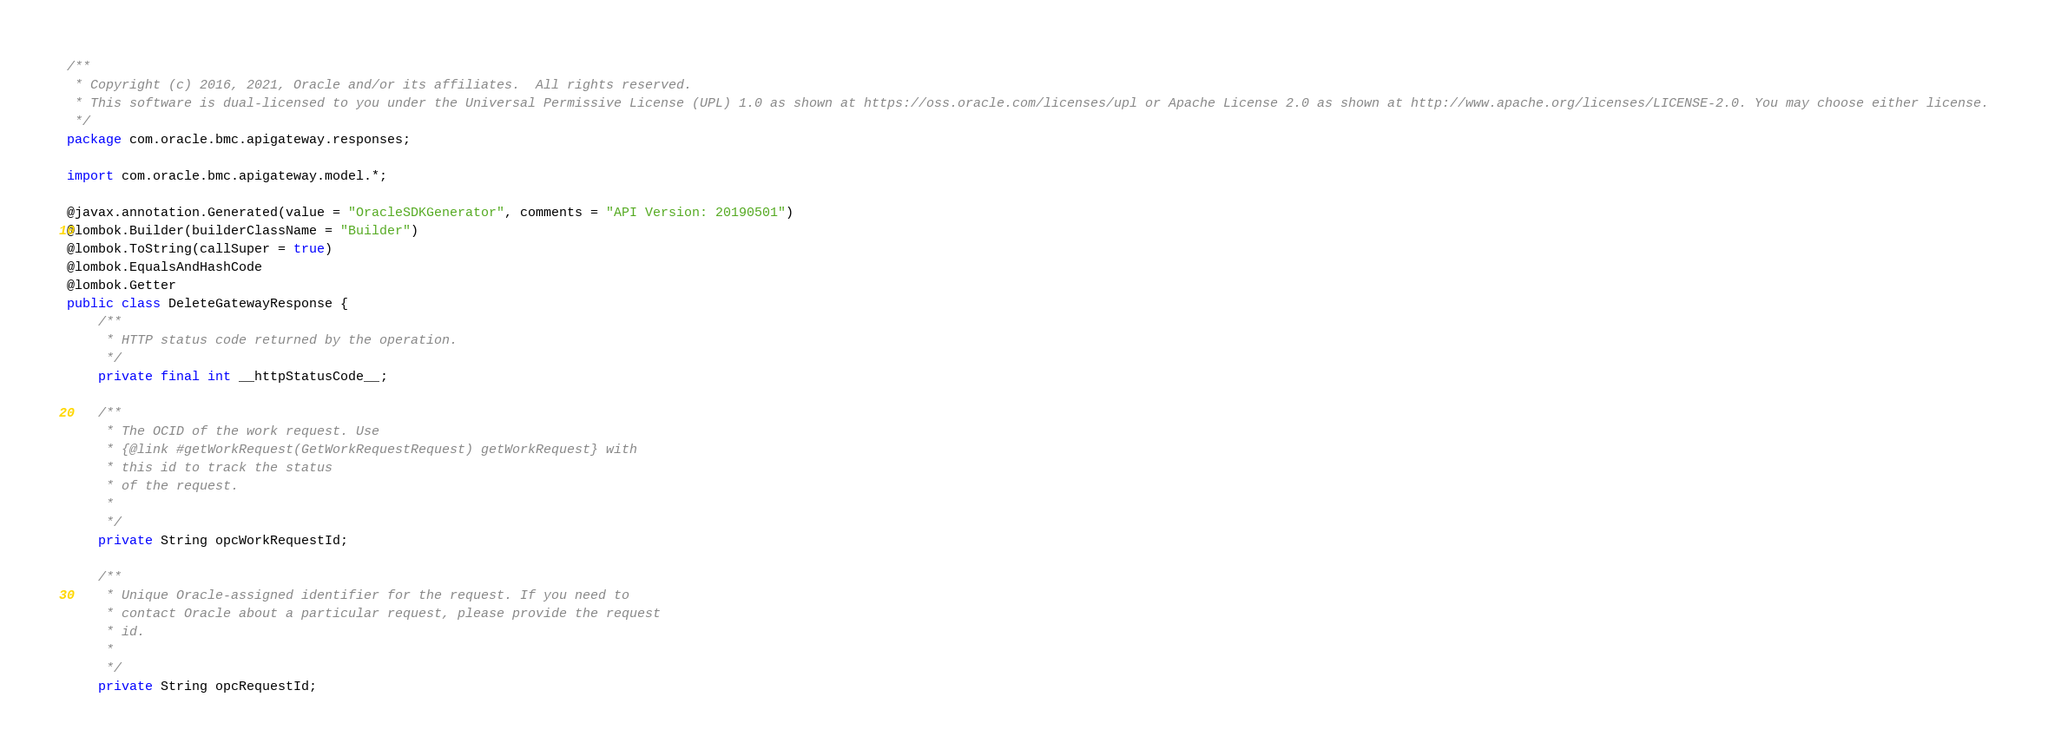Convert code to text. <code><loc_0><loc_0><loc_500><loc_500><_Java_>/**
 * Copyright (c) 2016, 2021, Oracle and/or its affiliates.  All rights reserved.
 * This software is dual-licensed to you under the Universal Permissive License (UPL) 1.0 as shown at https://oss.oracle.com/licenses/upl or Apache License 2.0 as shown at http://www.apache.org/licenses/LICENSE-2.0. You may choose either license.
 */
package com.oracle.bmc.apigateway.responses;

import com.oracle.bmc.apigateway.model.*;

@javax.annotation.Generated(value = "OracleSDKGenerator", comments = "API Version: 20190501")
@lombok.Builder(builderClassName = "Builder")
@lombok.ToString(callSuper = true)
@lombok.EqualsAndHashCode
@lombok.Getter
public class DeleteGatewayResponse {
    /**
     * HTTP status code returned by the operation.
     */
    private final int __httpStatusCode__;

    /**
     * The OCID of the work request. Use
     * {@link #getWorkRequest(GetWorkRequestRequest) getWorkRequest} with
     * this id to track the status
     * of the request.
     *
     */
    private String opcWorkRequestId;

    /**
     * Unique Oracle-assigned identifier for the request. If you need to
     * contact Oracle about a particular request, please provide the request
     * id.
     *
     */
    private String opcRequestId;
</code> 